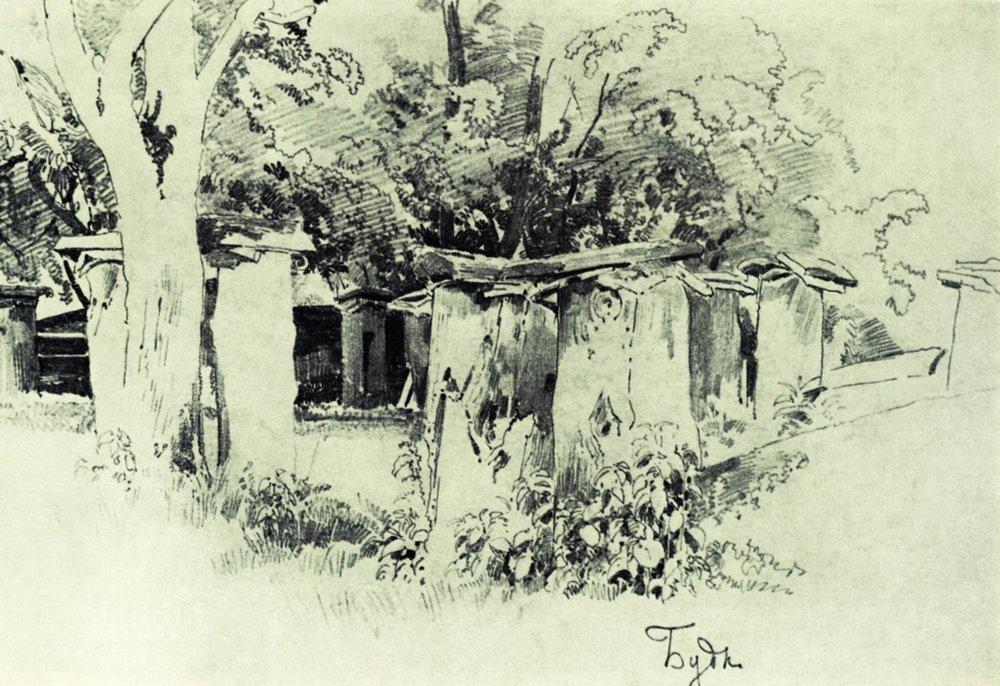What might be the historical or cultural context of this setting? The style and subject of the sketch suggest it depicts rural life in a timeless setting, possibly reminiscent of early 20th-century European countrysides. The architecture, with its simple, thatched roofs and modest construction, points to a community living in harmony with nature, potentially during a period where such rural landscapes were common, before the spread of industrialization. The artist's rendition may be a nostalgic homage to a simpler, more tranquil way of life. 